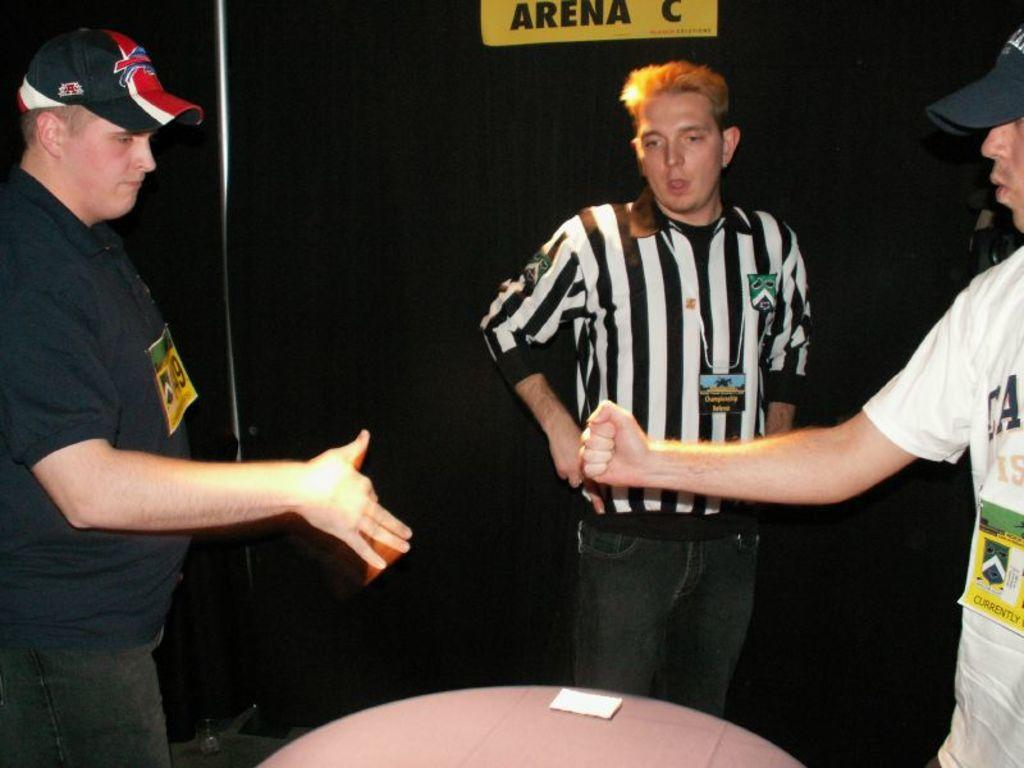<image>
Describe the image concisely. Two men about to shake hands under a sign that says Arena C. 